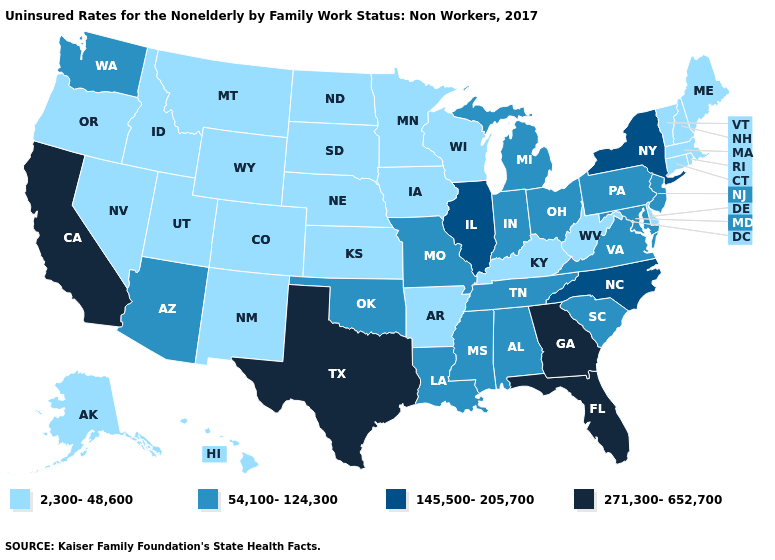Which states have the lowest value in the USA?
Answer briefly. Alaska, Arkansas, Colorado, Connecticut, Delaware, Hawaii, Idaho, Iowa, Kansas, Kentucky, Maine, Massachusetts, Minnesota, Montana, Nebraska, Nevada, New Hampshire, New Mexico, North Dakota, Oregon, Rhode Island, South Dakota, Utah, Vermont, West Virginia, Wisconsin, Wyoming. Among the states that border Iowa , does South Dakota have the lowest value?
Keep it brief. Yes. What is the value of Kansas?
Quick response, please. 2,300-48,600. Does Kansas have the highest value in the USA?
Be succinct. No. What is the value of Oregon?
Answer briefly. 2,300-48,600. What is the lowest value in the Northeast?
Answer briefly. 2,300-48,600. What is the value of Georgia?
Answer briefly. 271,300-652,700. Does Georgia have the highest value in the South?
Keep it brief. Yes. What is the lowest value in states that border Virginia?
Be succinct. 2,300-48,600. Name the states that have a value in the range 2,300-48,600?
Keep it brief. Alaska, Arkansas, Colorado, Connecticut, Delaware, Hawaii, Idaho, Iowa, Kansas, Kentucky, Maine, Massachusetts, Minnesota, Montana, Nebraska, Nevada, New Hampshire, New Mexico, North Dakota, Oregon, Rhode Island, South Dakota, Utah, Vermont, West Virginia, Wisconsin, Wyoming. Is the legend a continuous bar?
Quick response, please. No. Which states hav the highest value in the MidWest?
Write a very short answer. Illinois. Does Georgia have the lowest value in the South?
Short answer required. No. Does Florida have the highest value in the USA?
Quick response, please. Yes. Name the states that have a value in the range 54,100-124,300?
Be succinct. Alabama, Arizona, Indiana, Louisiana, Maryland, Michigan, Mississippi, Missouri, New Jersey, Ohio, Oklahoma, Pennsylvania, South Carolina, Tennessee, Virginia, Washington. 